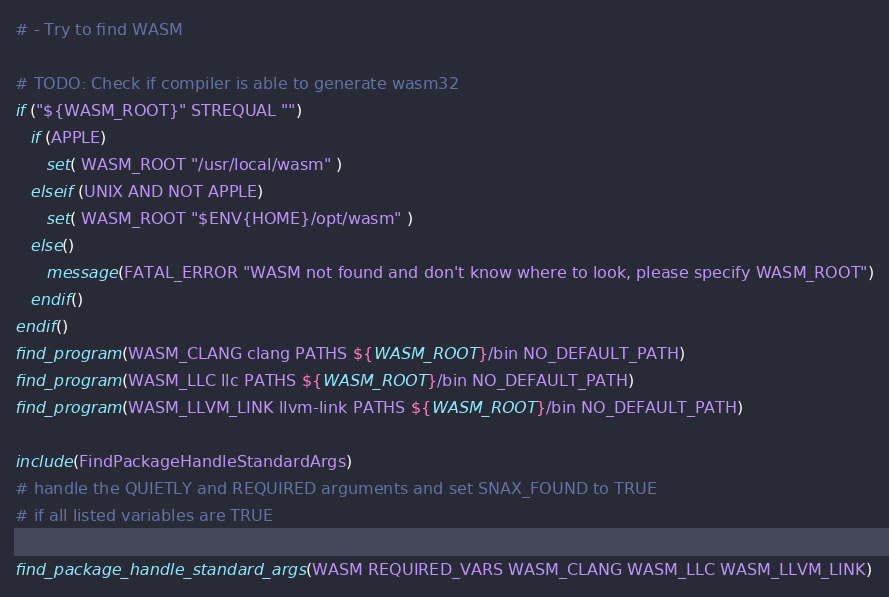<code> <loc_0><loc_0><loc_500><loc_500><_CMake_># - Try to find WASM

# TODO: Check if compiler is able to generate wasm32
if ("${WASM_ROOT}" STREQUAL "")
   if (APPLE)
      set( WASM_ROOT "/usr/local/wasm" )
   elseif (UNIX AND NOT APPLE)
      set( WASM_ROOT "$ENV{HOME}/opt/wasm" )
   else()
      message(FATAL_ERROR "WASM not found and don't know where to look, please specify WASM_ROOT")
   endif()
endif()
find_program(WASM_CLANG clang PATHS ${WASM_ROOT}/bin NO_DEFAULT_PATH)
find_program(WASM_LLC llc PATHS ${WASM_ROOT}/bin NO_DEFAULT_PATH)
find_program(WASM_LLVM_LINK llvm-link PATHS ${WASM_ROOT}/bin NO_DEFAULT_PATH)

include(FindPackageHandleStandardArgs)
# handle the QUIETLY and REQUIRED arguments and set SNAX_FOUND to TRUE
# if all listed variables are TRUE

find_package_handle_standard_args(WASM REQUIRED_VARS WASM_CLANG WASM_LLC WASM_LLVM_LINK)

</code> 